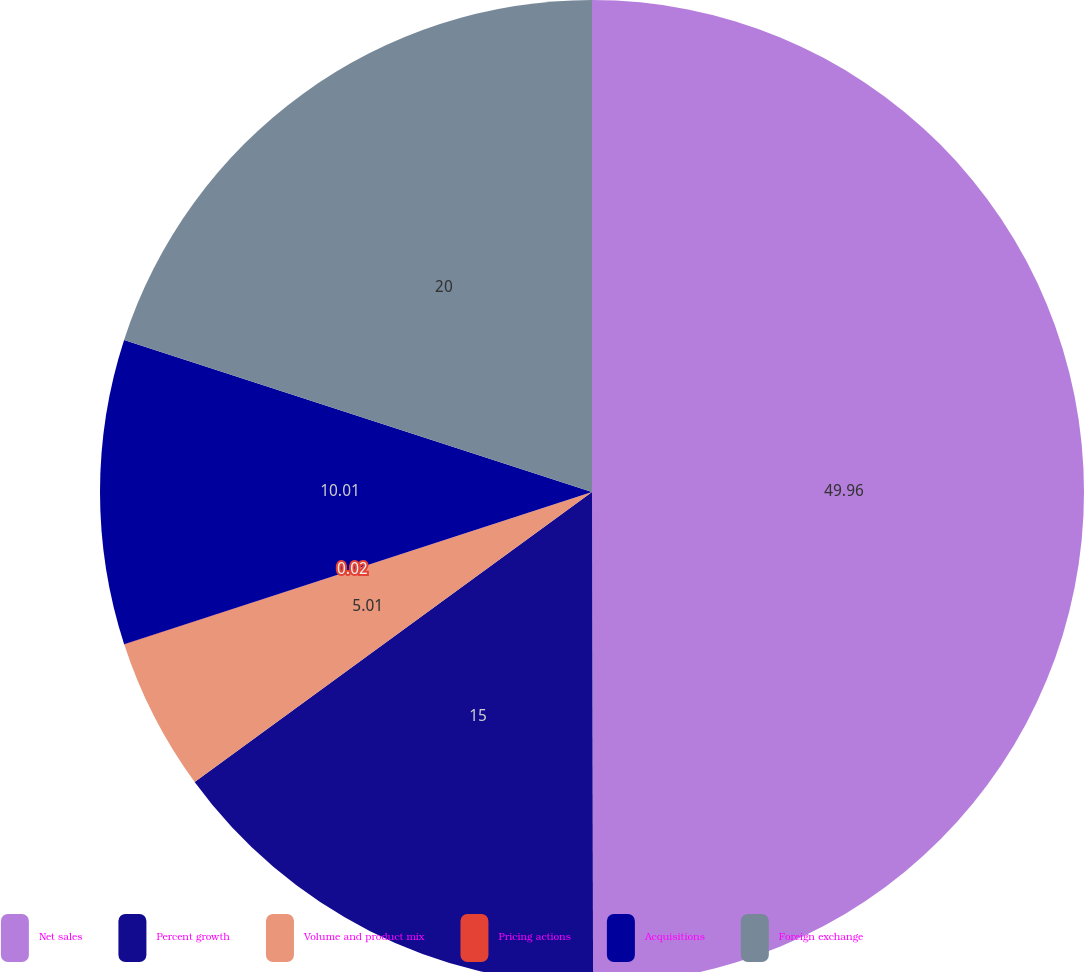<chart> <loc_0><loc_0><loc_500><loc_500><pie_chart><fcel>Net sales<fcel>Percent growth<fcel>Volume and product mix<fcel>Pricing actions<fcel>Acquisitions<fcel>Foreign exchange<nl><fcel>49.97%<fcel>15.0%<fcel>5.01%<fcel>0.02%<fcel>10.01%<fcel>20.0%<nl></chart> 